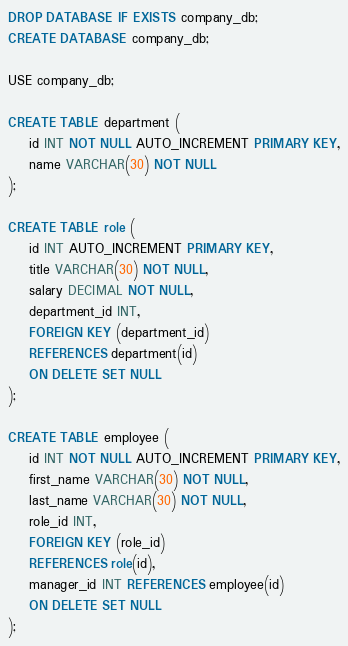Convert code to text. <code><loc_0><loc_0><loc_500><loc_500><_SQL_>DROP DATABASE IF EXISTS company_db;
CREATE DATABASE company_db;

USE company_db;

CREATE TABLE department (
    id INT NOT NULL AUTO_INCREMENT PRIMARY KEY,
    name VARCHAR(30) NOT NULL
);

CREATE TABLE role (
    id INT AUTO_INCREMENT PRIMARY KEY,
    title VARCHAR(30) NOT NULL,
    salary DECIMAL NOT NULL,
    department_id INT,
    FOREIGN KEY (department_id)
    REFERENCES department(id)
    ON DELETE SET NULL
);

CREATE TABLE employee (
    id INT NOT NULL AUTO_INCREMENT PRIMARY KEY,
    first_name VARCHAR(30) NOT NULL,
    last_name VARCHAR(30) NOT NULL,
    role_id INT,
    FOREIGN KEY (role_id)
    REFERENCES role(id),
    manager_id INT REFERENCES employee(id)
    ON DELETE SET NULL
);</code> 